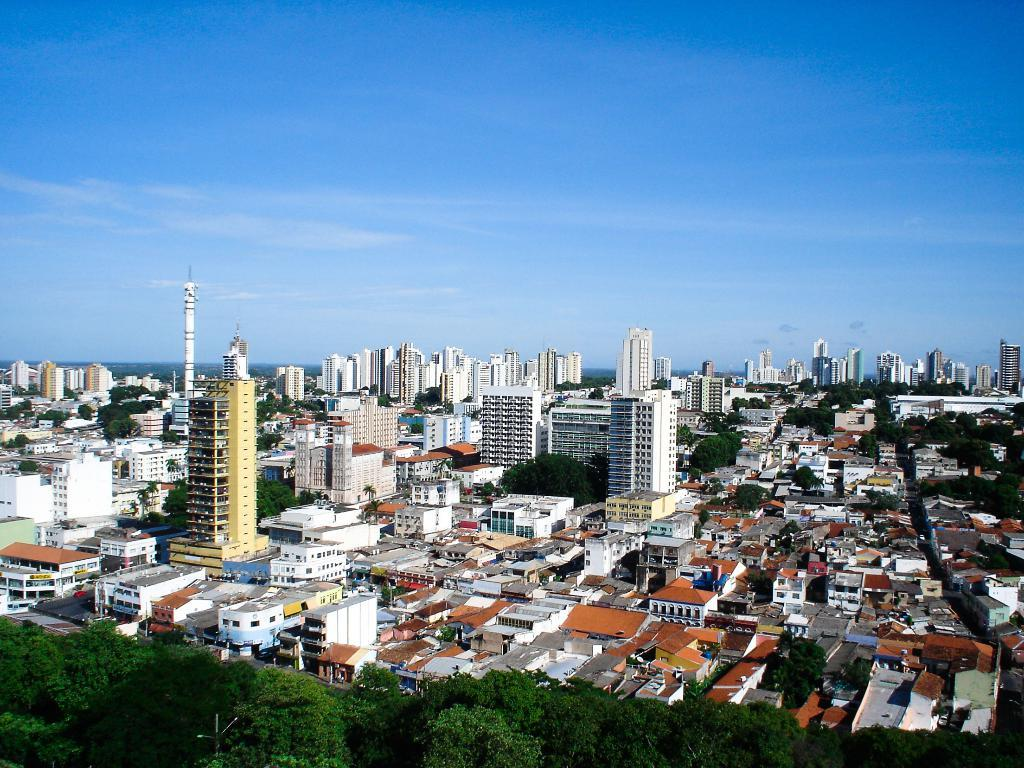What type of scene is depicted in the image? The image is a view of a city. What structures can be seen in the image? There are buildings in the image. Are there any natural elements present in the image? Yes, there are trees in the image. What can be seen in the distance in the image? The sky is visible in the background of the image. What is the purpose of the bomb in the image? There is no bomb present in the image. What does the taste of the trees in the image suggest about their age? Trees do not have a taste, and there is no information about their age in the image. 